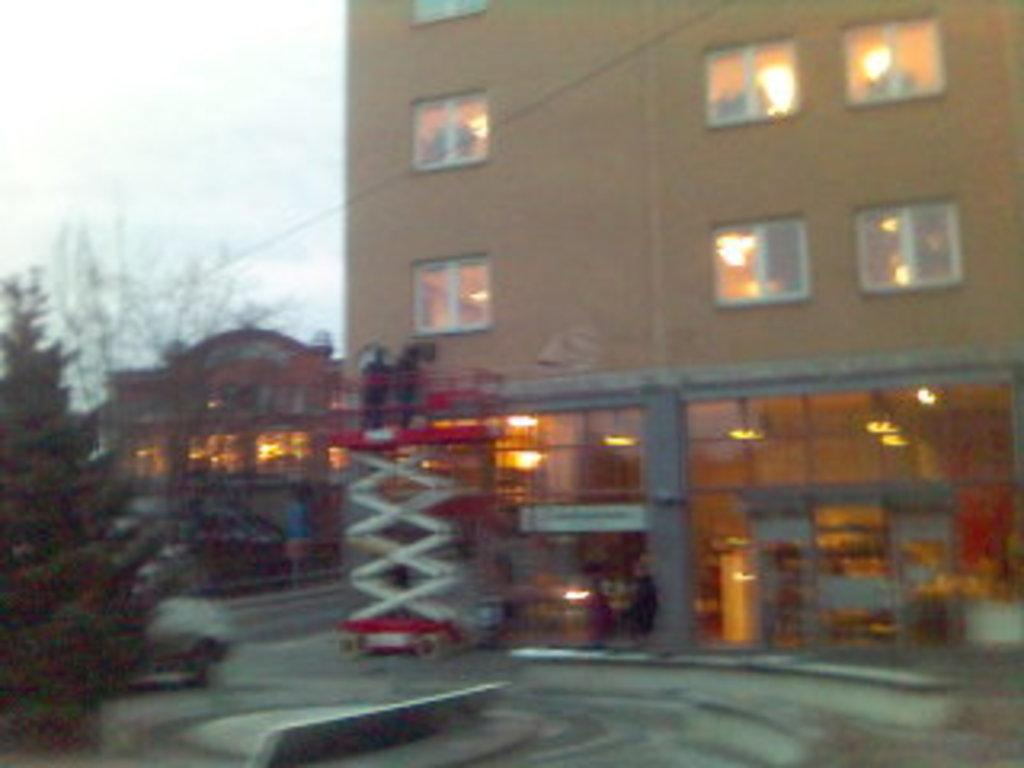What type of structures can be seen in the image? There are buildings in the image. What other natural elements are present in the image? There are trees in the image. What mode of transportation is visible in the image? There is a vehicle in the image. Are there any living beings present in the image? Yes, there are people in the image. What type of illumination can be seen in the image? There are lights in the image. What part of the natural environment is visible in the image? The sky is visible in the image. Can you describe any unspecified objects in the image? There are unspecified objects in the image, but their details are not provided. Can you see any steam coming from the hill in the image? There is no hill or steam present in the image. What type of arch can be seen in the image? There is no arch present in the image. 